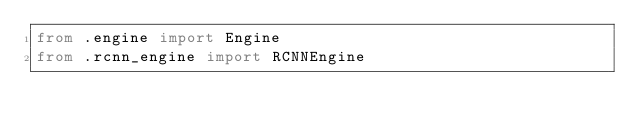Convert code to text. <code><loc_0><loc_0><loc_500><loc_500><_Python_>from .engine import Engine
from .rcnn_engine import RCNNEngine
</code> 